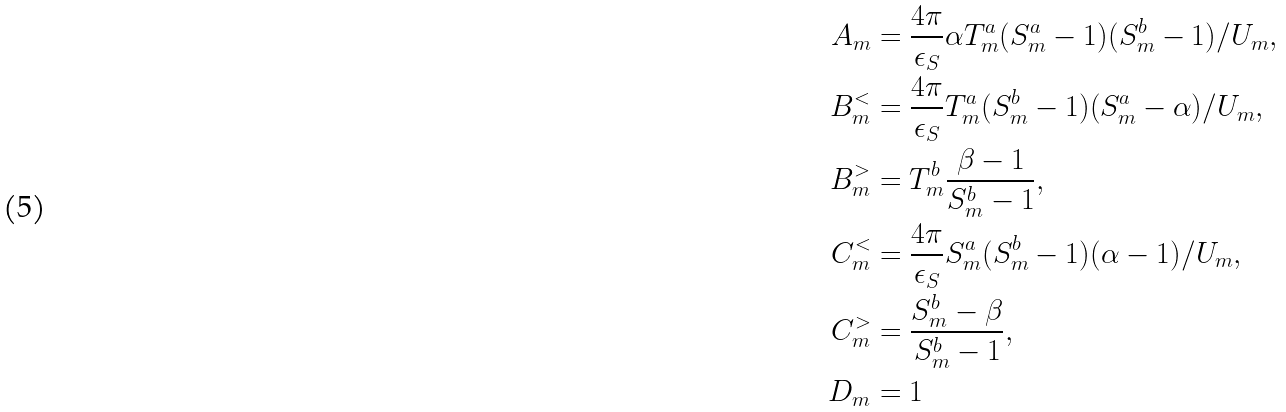<formula> <loc_0><loc_0><loc_500><loc_500>A _ { m } & = \frac { 4 \pi } { \epsilon _ { S } } \alpha T _ { m } ^ { a } ( S _ { m } ^ { a } - 1 ) ( S _ { m } ^ { b } - 1 ) / U _ { m } , \\ B _ { m } ^ { < } & = \frac { 4 \pi } { \epsilon _ { S } } T _ { m } ^ { a } ( S _ { m } ^ { b } - 1 ) ( S _ { m } ^ { a } - \alpha ) / U _ { m } , \\ B _ { m } ^ { > } & = T _ { m } ^ { b } \frac { \beta - 1 } { S _ { m } ^ { b } - 1 } , \\ C _ { m } ^ { < } & = \frac { 4 \pi } { \epsilon _ { S } } S _ { m } ^ { a } ( S _ { m } ^ { b } - 1 ) ( \alpha - 1 ) / U _ { m } , \\ C _ { m } ^ { > } & = \frac { S _ { m } ^ { b } - \beta } { S _ { m } ^ { b } - 1 } , \\ D _ { m } & = 1</formula> 